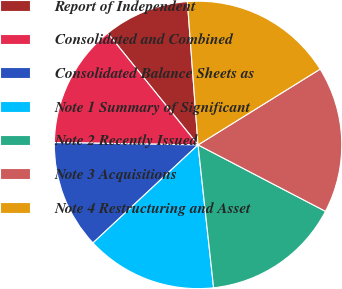Convert chart to OTSL. <chart><loc_0><loc_0><loc_500><loc_500><pie_chart><fcel>Report of Independent<fcel>Consolidated and Combined<fcel>Consolidated Balance Sheets as<fcel>Note 1 Summary of Significant<fcel>Note 2 Recently Issued<fcel>Note 3 Acquisitions<fcel>Note 4 Restructuring and Asset<nl><fcel>9.64%<fcel>13.92%<fcel>12.21%<fcel>14.78%<fcel>15.63%<fcel>16.49%<fcel>17.34%<nl></chart> 